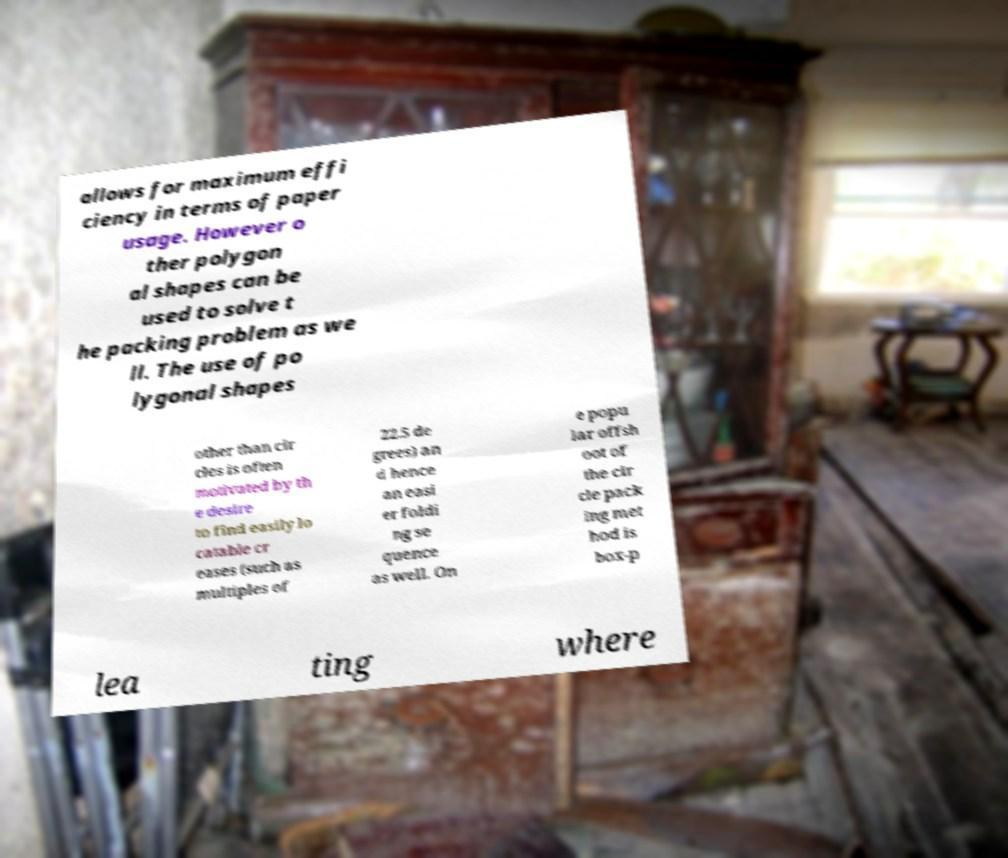There's text embedded in this image that I need extracted. Can you transcribe it verbatim? allows for maximum effi ciency in terms of paper usage. However o ther polygon al shapes can be used to solve t he packing problem as we ll. The use of po lygonal shapes other than cir cles is often motivated by th e desire to find easily lo catable cr eases (such as multiples of 22.5 de grees) an d hence an easi er foldi ng se quence as well. On e popu lar offsh oot of the cir cle pack ing met hod is box-p lea ting where 